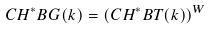<formula> <loc_0><loc_0><loc_500><loc_500>C H ^ { * } B G ( k ) = ( C H ^ { * } B T ( k ) ) ^ { W }</formula> 